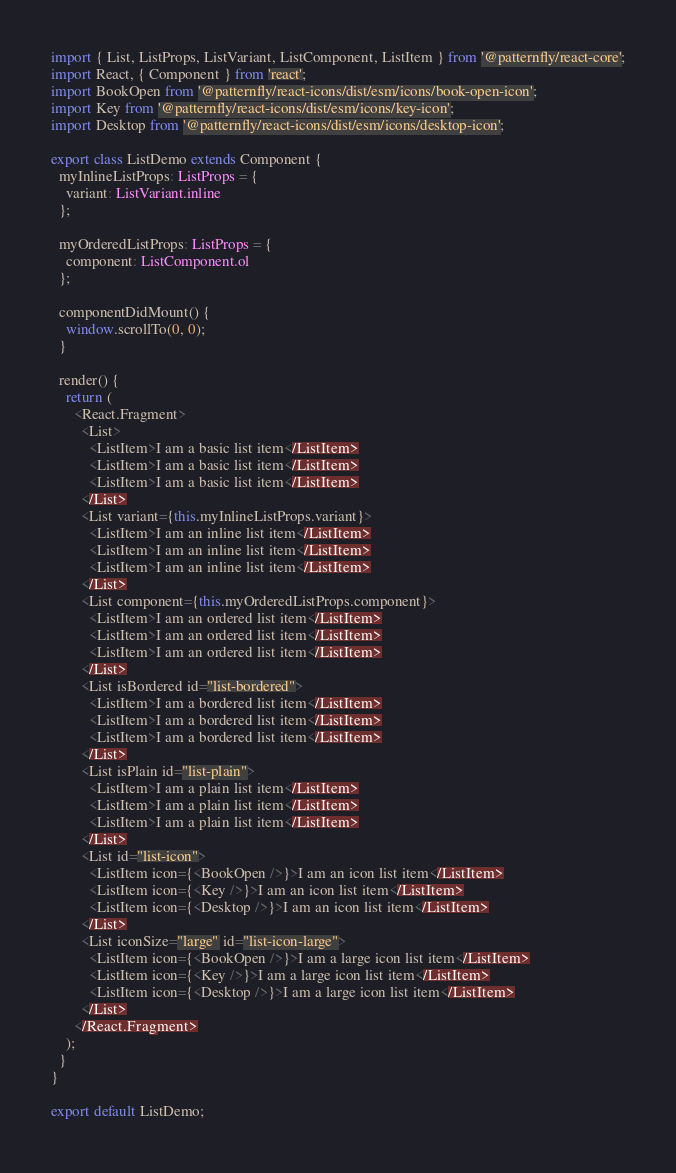Convert code to text. <code><loc_0><loc_0><loc_500><loc_500><_TypeScript_>import { List, ListProps, ListVariant, ListComponent, ListItem } from '@patternfly/react-core';
import React, { Component } from 'react';
import BookOpen from '@patternfly/react-icons/dist/esm/icons/book-open-icon';
import Key from '@patternfly/react-icons/dist/esm/icons/key-icon';
import Desktop from '@patternfly/react-icons/dist/esm/icons/desktop-icon';

export class ListDemo extends Component {
  myInlineListProps: ListProps = {
    variant: ListVariant.inline
  };

  myOrderedListProps: ListProps = {
    component: ListComponent.ol
  };

  componentDidMount() {
    window.scrollTo(0, 0);
  }

  render() {
    return (
      <React.Fragment>
        <List>
          <ListItem>I am a basic list item</ListItem>
          <ListItem>I am a basic list item</ListItem>
          <ListItem>I am a basic list item</ListItem>
        </List>
        <List variant={this.myInlineListProps.variant}>
          <ListItem>I am an inline list item</ListItem>
          <ListItem>I am an inline list item</ListItem>
          <ListItem>I am an inline list item</ListItem>
        </List>
        <List component={this.myOrderedListProps.component}>
          <ListItem>I am an ordered list item</ListItem>
          <ListItem>I am an ordered list item</ListItem>
          <ListItem>I am an ordered list item</ListItem>
        </List>
        <List isBordered id="list-bordered">
          <ListItem>I am a bordered list item</ListItem>
          <ListItem>I am a bordered list item</ListItem>
          <ListItem>I am a bordered list item</ListItem>
        </List>
        <List isPlain id="list-plain">
          <ListItem>I am a plain list item</ListItem>
          <ListItem>I am a plain list item</ListItem>
          <ListItem>I am a plain list item</ListItem>
        </List>
        <List id="list-icon">
          <ListItem icon={<BookOpen />}>I am an icon list item</ListItem>
          <ListItem icon={<Key />}>I am an icon list item</ListItem>
          <ListItem icon={<Desktop />}>I am an icon list item</ListItem>
        </List>
        <List iconSize="large" id="list-icon-large">
          <ListItem icon={<BookOpen />}>I am a large icon list item</ListItem>
          <ListItem icon={<Key />}>I am a large icon list item</ListItem>
          <ListItem icon={<Desktop />}>I am a large icon list item</ListItem>
        </List>
      </React.Fragment>
    );
  }
}

export default ListDemo;
</code> 